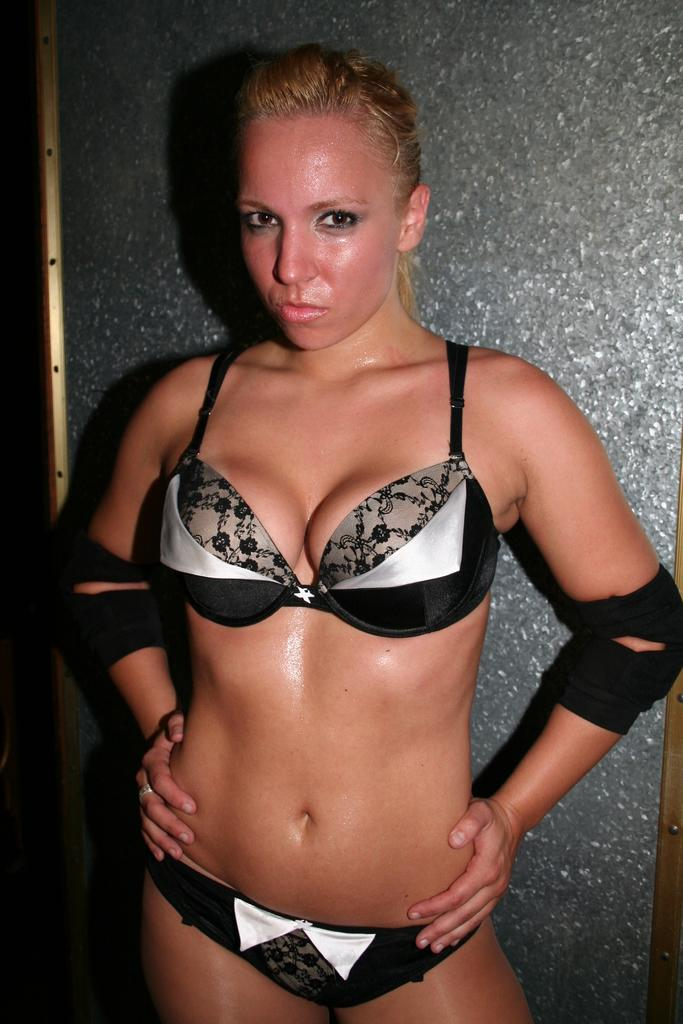What is the main subject in the foreground of the image? There is a woman standing in the foreground of the image. What can be seen in the background of the image? There appears to be a wall in the background of the image. How many chickens are visible in the image? There are no chickens present in the image. What type of error can be seen in the image? There is no error visible in the image. 